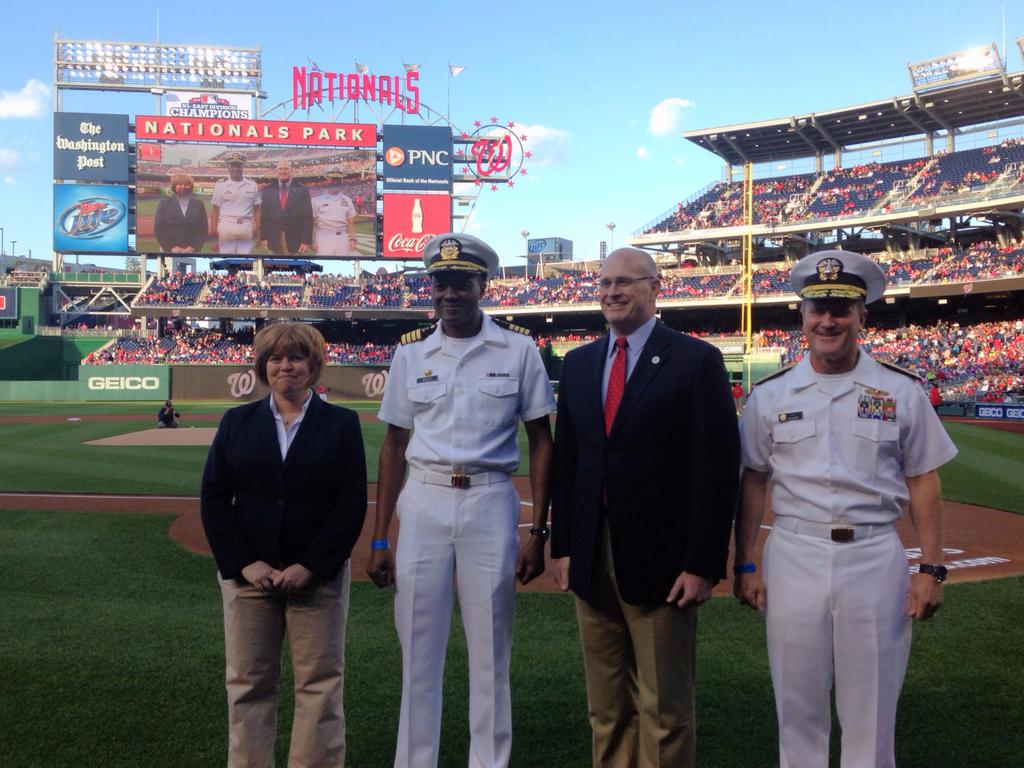What is the name of this stadium?
Keep it short and to the point. Nationals park. 